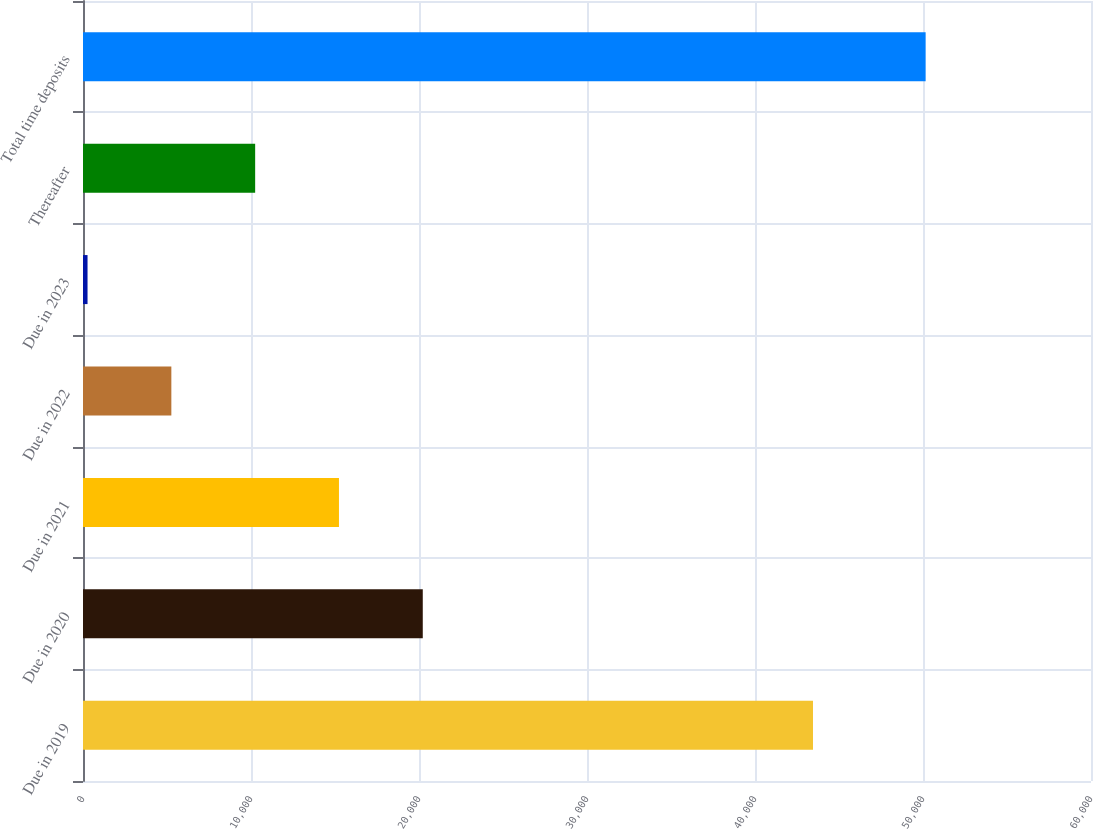Convert chart. <chart><loc_0><loc_0><loc_500><loc_500><bar_chart><fcel>Due in 2019<fcel>Due in 2020<fcel>Due in 2021<fcel>Due in 2022<fcel>Due in 2023<fcel>Thereafter<fcel>Total time deposits<nl><fcel>43452<fcel>20224.8<fcel>15236.1<fcel>5258.7<fcel>270<fcel>10247.4<fcel>50157<nl></chart> 